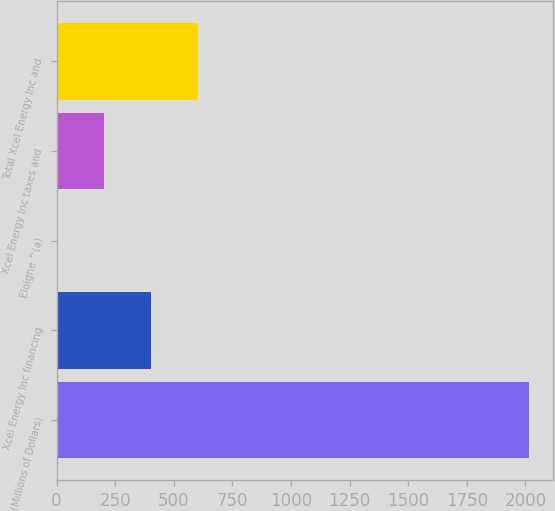Convert chart to OTSL. <chart><loc_0><loc_0><loc_500><loc_500><bar_chart><fcel>(Millions of Dollars)<fcel>Xcel Energy Inc financing<fcel>Eloigne ^(a)<fcel>Xcel Energy Inc taxes and<fcel>Total Xcel Energy Inc and<nl><fcel>2015<fcel>403.08<fcel>0.1<fcel>201.59<fcel>604.57<nl></chart> 